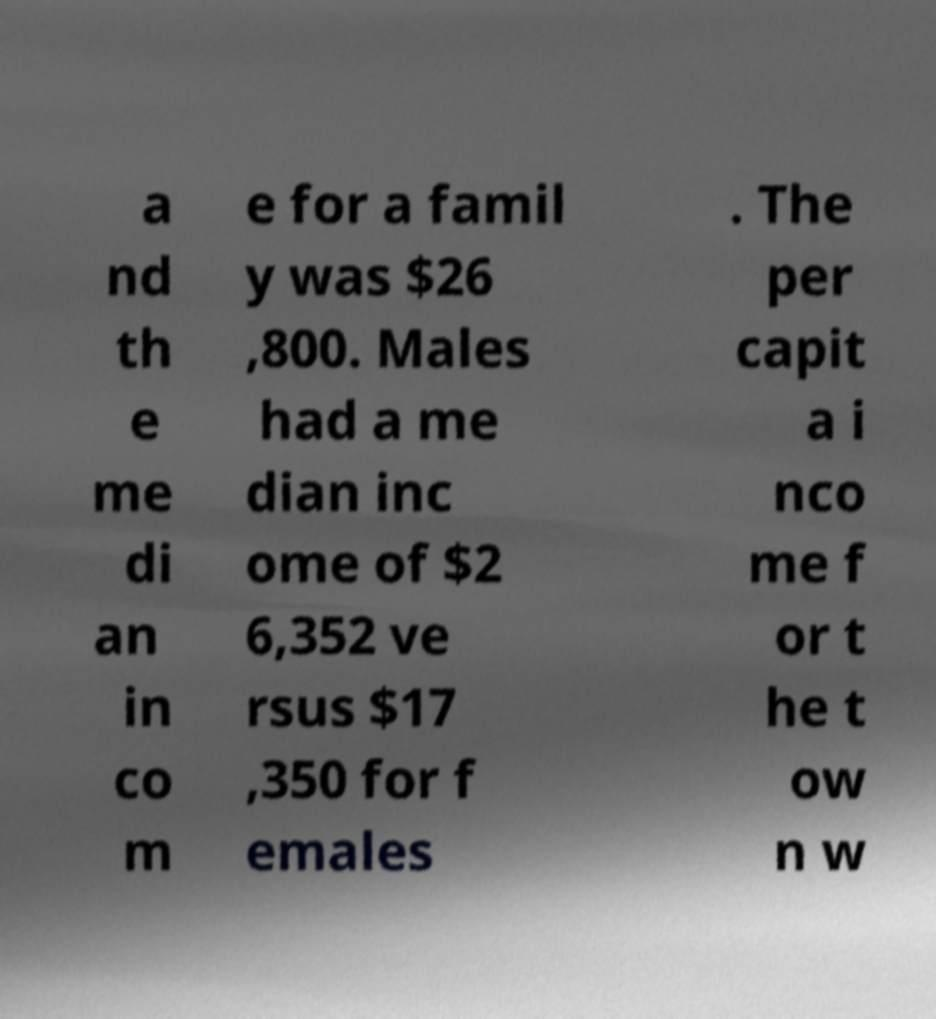Can you read and provide the text displayed in the image?This photo seems to have some interesting text. Can you extract and type it out for me? a nd th e me di an in co m e for a famil y was $26 ,800. Males had a me dian inc ome of $2 6,352 ve rsus $17 ,350 for f emales . The per capit a i nco me f or t he t ow n w 